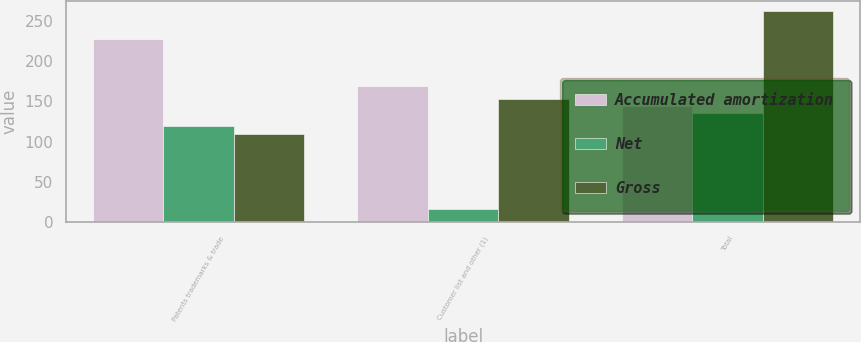Convert chart to OTSL. <chart><loc_0><loc_0><loc_500><loc_500><stacked_bar_chart><ecel><fcel>Patents trademarks & trade<fcel>Customer list and other (1)<fcel>Total<nl><fcel>Accumulated amortization<fcel>228<fcel>169<fcel>144<nl><fcel>Net<fcel>119<fcel>16<fcel>135<nl><fcel>Gross<fcel>109<fcel>153<fcel>262<nl></chart> 